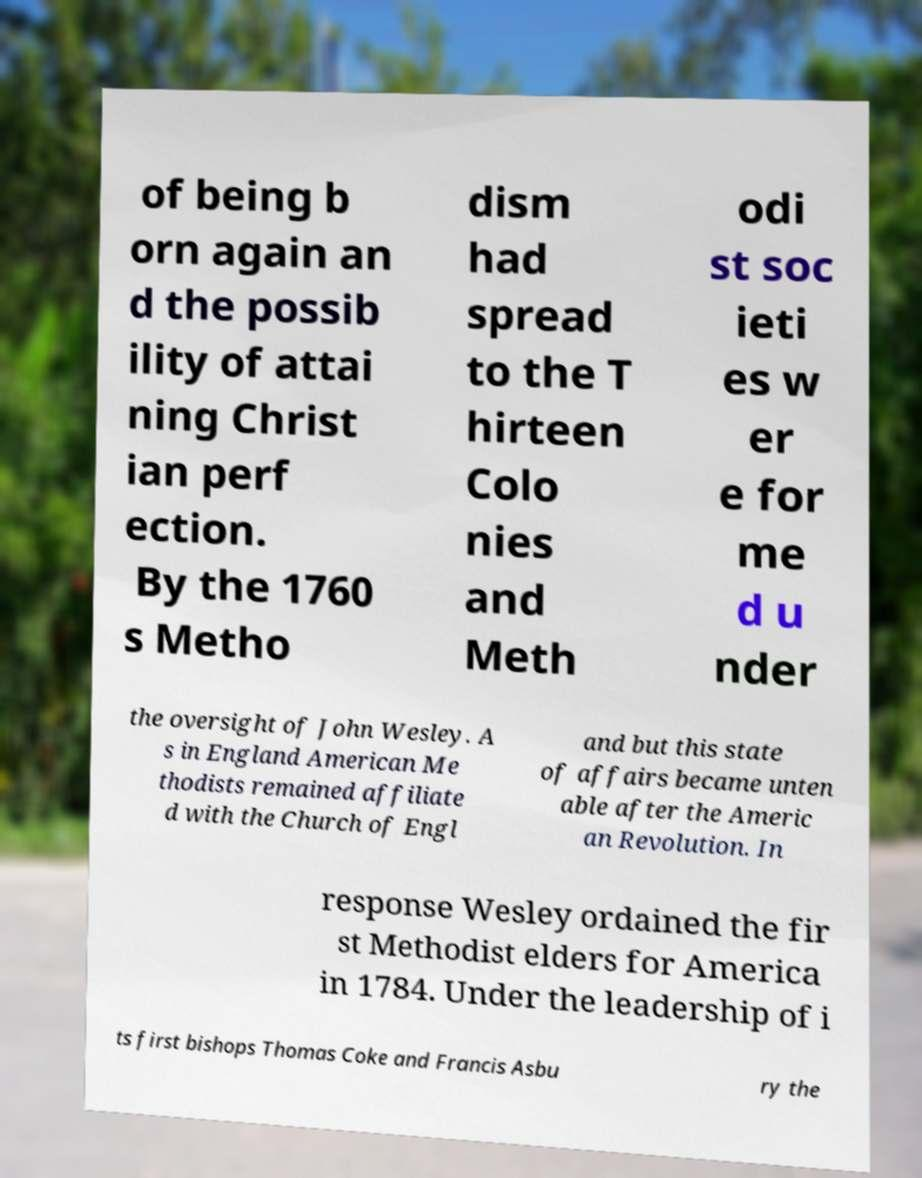Please read and relay the text visible in this image. What does it say? of being b orn again an d the possib ility of attai ning Christ ian perf ection. By the 1760 s Metho dism had spread to the T hirteen Colo nies and Meth odi st soc ieti es w er e for me d u nder the oversight of John Wesley. A s in England American Me thodists remained affiliate d with the Church of Engl and but this state of affairs became unten able after the Americ an Revolution. In response Wesley ordained the fir st Methodist elders for America in 1784. Under the leadership of i ts first bishops Thomas Coke and Francis Asbu ry the 